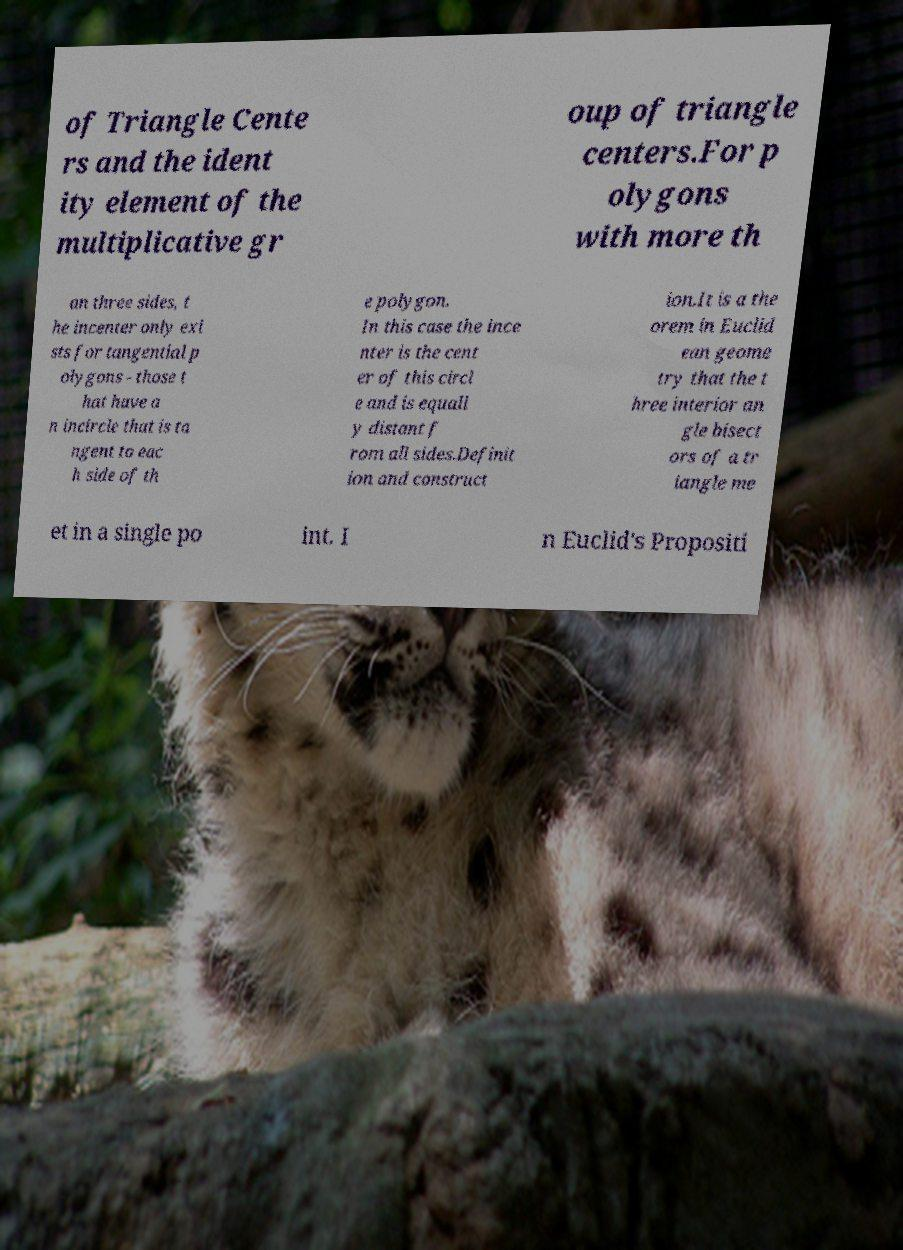Please read and relay the text visible in this image. What does it say? of Triangle Cente rs and the ident ity element of the multiplicative gr oup of triangle centers.For p olygons with more th an three sides, t he incenter only exi sts for tangential p olygons - those t hat have a n incircle that is ta ngent to eac h side of th e polygon. In this case the ince nter is the cent er of this circl e and is equall y distant f rom all sides.Definit ion and construct ion.It is a the orem in Euclid ean geome try that the t hree interior an gle bisect ors of a tr iangle me et in a single po int. I n Euclid's Propositi 